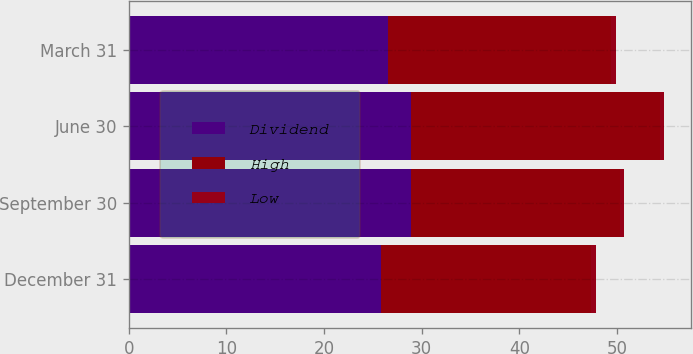Convert chart to OTSL. <chart><loc_0><loc_0><loc_500><loc_500><stacked_bar_chart><ecel><fcel>December 31<fcel>September 30<fcel>June 30<fcel>March 31<nl><fcel>Dividend<fcel>25.84<fcel>28.88<fcel>28.95<fcel>26.5<nl><fcel>High<fcel>21.5<fcel>21.4<fcel>25.46<fcel>22.92<nl><fcel>Low<fcel>0.46<fcel>0.46<fcel>0.45<fcel>0.45<nl></chart> 